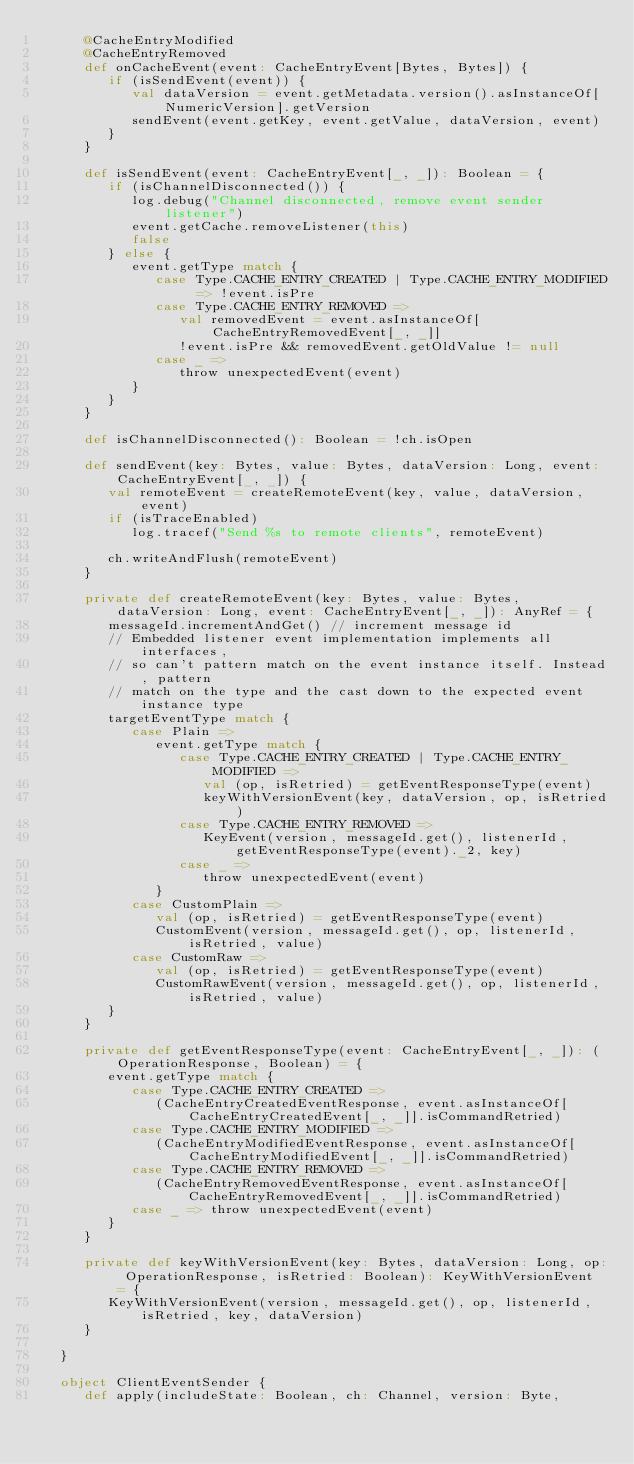<code> <loc_0><loc_0><loc_500><loc_500><_Scala_>      @CacheEntryModified
      @CacheEntryRemoved
      def onCacheEvent(event: CacheEntryEvent[Bytes, Bytes]) {
         if (isSendEvent(event)) {
            val dataVersion = event.getMetadata.version().asInstanceOf[NumericVersion].getVersion
            sendEvent(event.getKey, event.getValue, dataVersion, event)
         }
      }

      def isSendEvent(event: CacheEntryEvent[_, _]): Boolean = {
         if (isChannelDisconnected()) {
            log.debug("Channel disconnected, remove event sender listener")
            event.getCache.removeListener(this)
            false
         } else {
            event.getType match {
               case Type.CACHE_ENTRY_CREATED | Type.CACHE_ENTRY_MODIFIED => !event.isPre
               case Type.CACHE_ENTRY_REMOVED =>
                  val removedEvent = event.asInstanceOf[CacheEntryRemovedEvent[_, _]]
                  !event.isPre && removedEvent.getOldValue != null
               case _ =>
                  throw unexpectedEvent(event)
            }
         }
      }

      def isChannelDisconnected(): Boolean = !ch.isOpen

      def sendEvent(key: Bytes, value: Bytes, dataVersion: Long, event: CacheEntryEvent[_, _]) {
         val remoteEvent = createRemoteEvent(key, value, dataVersion, event)
         if (isTraceEnabled)
            log.tracef("Send %s to remote clients", remoteEvent)

         ch.writeAndFlush(remoteEvent)
      }

      private def createRemoteEvent(key: Bytes, value: Bytes, dataVersion: Long, event: CacheEntryEvent[_, _]): AnyRef = {
         messageId.incrementAndGet() // increment message id
         // Embedded listener event implementation implements all interfaces,
         // so can't pattern match on the event instance itself. Instead, pattern
         // match on the type and the cast down to the expected event instance type
         targetEventType match {
            case Plain =>
               event.getType match {
                  case Type.CACHE_ENTRY_CREATED | Type.CACHE_ENTRY_MODIFIED =>
                     val (op, isRetried) = getEventResponseType(event)
                     keyWithVersionEvent(key, dataVersion, op, isRetried)
                  case Type.CACHE_ENTRY_REMOVED =>
                     KeyEvent(version, messageId.get(), listenerId, getEventResponseType(event)._2, key)
                  case _ =>
                     throw unexpectedEvent(event)
               }
            case CustomPlain =>
               val (op, isRetried) = getEventResponseType(event)
               CustomEvent(version, messageId.get(), op, listenerId, isRetried, value)
            case CustomRaw =>
               val (op, isRetried) = getEventResponseType(event)
               CustomRawEvent(version, messageId.get(), op, listenerId, isRetried, value)
         }
      }

      private def getEventResponseType(event: CacheEntryEvent[_, _]): (OperationResponse, Boolean) = {
         event.getType match {
            case Type.CACHE_ENTRY_CREATED =>
               (CacheEntryCreatedEventResponse, event.asInstanceOf[CacheEntryCreatedEvent[_, _]].isCommandRetried)
            case Type.CACHE_ENTRY_MODIFIED =>
               (CacheEntryModifiedEventResponse, event.asInstanceOf[CacheEntryModifiedEvent[_, _]].isCommandRetried)
            case Type.CACHE_ENTRY_REMOVED =>
               (CacheEntryRemovedEventResponse, event.asInstanceOf[CacheEntryRemovedEvent[_, _]].isCommandRetried)
            case _ => throw unexpectedEvent(event)
         }
      }

      private def keyWithVersionEvent(key: Bytes, dataVersion: Long, op: OperationResponse, isRetried: Boolean): KeyWithVersionEvent = {
         KeyWithVersionEvent(version, messageId.get(), op, listenerId, isRetried, key, dataVersion)
      }

   }

   object ClientEventSender {
      def apply(includeState: Boolean, ch: Channel, version: Byte,</code> 